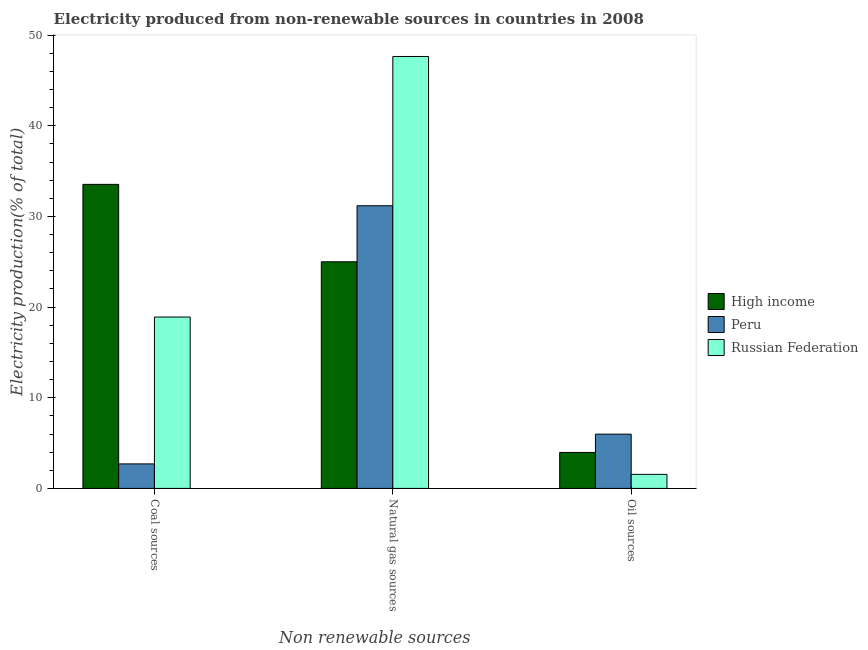How many different coloured bars are there?
Your response must be concise. 3. How many groups of bars are there?
Offer a very short reply. 3. How many bars are there on the 1st tick from the left?
Ensure brevity in your answer.  3. How many bars are there on the 3rd tick from the right?
Your answer should be compact. 3. What is the label of the 3rd group of bars from the left?
Make the answer very short. Oil sources. What is the percentage of electricity produced by natural gas in Peru?
Ensure brevity in your answer.  31.18. Across all countries, what is the maximum percentage of electricity produced by coal?
Provide a succinct answer. 33.54. Across all countries, what is the minimum percentage of electricity produced by coal?
Offer a terse response. 2.7. What is the total percentage of electricity produced by oil sources in the graph?
Provide a short and direct response. 11.5. What is the difference between the percentage of electricity produced by coal in Peru and that in High income?
Make the answer very short. -30.83. What is the difference between the percentage of electricity produced by natural gas in Peru and the percentage of electricity produced by coal in Russian Federation?
Give a very brief answer. 12.28. What is the average percentage of electricity produced by coal per country?
Offer a terse response. 18.38. What is the difference between the percentage of electricity produced by natural gas and percentage of electricity produced by oil sources in Peru?
Your answer should be very brief. 25.19. What is the ratio of the percentage of electricity produced by coal in Russian Federation to that in Peru?
Offer a very short reply. 6.99. Is the percentage of electricity produced by oil sources in Russian Federation less than that in Peru?
Keep it short and to the point. Yes. What is the difference between the highest and the second highest percentage of electricity produced by oil sources?
Your answer should be very brief. 2.02. What is the difference between the highest and the lowest percentage of electricity produced by natural gas?
Offer a terse response. 22.65. In how many countries, is the percentage of electricity produced by coal greater than the average percentage of electricity produced by coal taken over all countries?
Ensure brevity in your answer.  2. What does the 1st bar from the left in Oil sources represents?
Give a very brief answer. High income. Is it the case that in every country, the sum of the percentage of electricity produced by coal and percentage of electricity produced by natural gas is greater than the percentage of electricity produced by oil sources?
Offer a terse response. Yes. Does the graph contain any zero values?
Provide a succinct answer. No. Where does the legend appear in the graph?
Your answer should be compact. Center right. How many legend labels are there?
Give a very brief answer. 3. What is the title of the graph?
Your answer should be very brief. Electricity produced from non-renewable sources in countries in 2008. Does "Swaziland" appear as one of the legend labels in the graph?
Provide a succinct answer. No. What is the label or title of the X-axis?
Your answer should be very brief. Non renewable sources. What is the label or title of the Y-axis?
Offer a terse response. Electricity production(% of total). What is the Electricity production(% of total) in High income in Coal sources?
Ensure brevity in your answer.  33.54. What is the Electricity production(% of total) of Peru in Coal sources?
Your response must be concise. 2.7. What is the Electricity production(% of total) of Russian Federation in Coal sources?
Offer a terse response. 18.9. What is the Electricity production(% of total) of High income in Natural gas sources?
Keep it short and to the point. 25. What is the Electricity production(% of total) of Peru in Natural gas sources?
Give a very brief answer. 31.18. What is the Electricity production(% of total) of Russian Federation in Natural gas sources?
Offer a very short reply. 47.64. What is the Electricity production(% of total) in High income in Oil sources?
Give a very brief answer. 3.97. What is the Electricity production(% of total) in Peru in Oil sources?
Your answer should be compact. 5.99. What is the Electricity production(% of total) in Russian Federation in Oil sources?
Make the answer very short. 1.55. Across all Non renewable sources, what is the maximum Electricity production(% of total) in High income?
Provide a succinct answer. 33.54. Across all Non renewable sources, what is the maximum Electricity production(% of total) in Peru?
Give a very brief answer. 31.18. Across all Non renewable sources, what is the maximum Electricity production(% of total) in Russian Federation?
Your answer should be compact. 47.64. Across all Non renewable sources, what is the minimum Electricity production(% of total) of High income?
Offer a terse response. 3.97. Across all Non renewable sources, what is the minimum Electricity production(% of total) in Peru?
Offer a terse response. 2.7. Across all Non renewable sources, what is the minimum Electricity production(% of total) in Russian Federation?
Give a very brief answer. 1.55. What is the total Electricity production(% of total) in High income in the graph?
Give a very brief answer. 62.5. What is the total Electricity production(% of total) in Peru in the graph?
Provide a short and direct response. 39.87. What is the total Electricity production(% of total) in Russian Federation in the graph?
Give a very brief answer. 68.09. What is the difference between the Electricity production(% of total) in High income in Coal sources and that in Natural gas sources?
Your answer should be compact. 8.54. What is the difference between the Electricity production(% of total) in Peru in Coal sources and that in Natural gas sources?
Offer a very short reply. -28.47. What is the difference between the Electricity production(% of total) in Russian Federation in Coal sources and that in Natural gas sources?
Your answer should be compact. -28.74. What is the difference between the Electricity production(% of total) of High income in Coal sources and that in Oil sources?
Your answer should be very brief. 29.57. What is the difference between the Electricity production(% of total) of Peru in Coal sources and that in Oil sources?
Your answer should be very brief. -3.28. What is the difference between the Electricity production(% of total) of Russian Federation in Coal sources and that in Oil sources?
Your response must be concise. 17.35. What is the difference between the Electricity production(% of total) in High income in Natural gas sources and that in Oil sources?
Your answer should be very brief. 21.03. What is the difference between the Electricity production(% of total) of Peru in Natural gas sources and that in Oil sources?
Your response must be concise. 25.19. What is the difference between the Electricity production(% of total) in Russian Federation in Natural gas sources and that in Oil sources?
Your answer should be very brief. 46.09. What is the difference between the Electricity production(% of total) of High income in Coal sources and the Electricity production(% of total) of Peru in Natural gas sources?
Make the answer very short. 2.36. What is the difference between the Electricity production(% of total) of High income in Coal sources and the Electricity production(% of total) of Russian Federation in Natural gas sources?
Keep it short and to the point. -14.11. What is the difference between the Electricity production(% of total) in Peru in Coal sources and the Electricity production(% of total) in Russian Federation in Natural gas sources?
Offer a very short reply. -44.94. What is the difference between the Electricity production(% of total) in High income in Coal sources and the Electricity production(% of total) in Peru in Oil sources?
Offer a very short reply. 27.55. What is the difference between the Electricity production(% of total) of High income in Coal sources and the Electricity production(% of total) of Russian Federation in Oil sources?
Give a very brief answer. 31.99. What is the difference between the Electricity production(% of total) of Peru in Coal sources and the Electricity production(% of total) of Russian Federation in Oil sources?
Make the answer very short. 1.16. What is the difference between the Electricity production(% of total) in High income in Natural gas sources and the Electricity production(% of total) in Peru in Oil sources?
Ensure brevity in your answer.  19.01. What is the difference between the Electricity production(% of total) of High income in Natural gas sources and the Electricity production(% of total) of Russian Federation in Oil sources?
Give a very brief answer. 23.45. What is the difference between the Electricity production(% of total) of Peru in Natural gas sources and the Electricity production(% of total) of Russian Federation in Oil sources?
Keep it short and to the point. 29.63. What is the average Electricity production(% of total) of High income per Non renewable sources?
Give a very brief answer. 20.83. What is the average Electricity production(% of total) in Peru per Non renewable sources?
Ensure brevity in your answer.  13.29. What is the average Electricity production(% of total) of Russian Federation per Non renewable sources?
Provide a short and direct response. 22.7. What is the difference between the Electricity production(% of total) of High income and Electricity production(% of total) of Peru in Coal sources?
Your response must be concise. 30.83. What is the difference between the Electricity production(% of total) in High income and Electricity production(% of total) in Russian Federation in Coal sources?
Provide a succinct answer. 14.63. What is the difference between the Electricity production(% of total) of Peru and Electricity production(% of total) of Russian Federation in Coal sources?
Your answer should be compact. -16.2. What is the difference between the Electricity production(% of total) in High income and Electricity production(% of total) in Peru in Natural gas sources?
Your answer should be compact. -6.18. What is the difference between the Electricity production(% of total) in High income and Electricity production(% of total) in Russian Federation in Natural gas sources?
Your answer should be very brief. -22.65. What is the difference between the Electricity production(% of total) of Peru and Electricity production(% of total) of Russian Federation in Natural gas sources?
Provide a short and direct response. -16.46. What is the difference between the Electricity production(% of total) in High income and Electricity production(% of total) in Peru in Oil sources?
Keep it short and to the point. -2.02. What is the difference between the Electricity production(% of total) in High income and Electricity production(% of total) in Russian Federation in Oil sources?
Provide a short and direct response. 2.42. What is the difference between the Electricity production(% of total) in Peru and Electricity production(% of total) in Russian Federation in Oil sources?
Keep it short and to the point. 4.44. What is the ratio of the Electricity production(% of total) in High income in Coal sources to that in Natural gas sources?
Provide a short and direct response. 1.34. What is the ratio of the Electricity production(% of total) of Peru in Coal sources to that in Natural gas sources?
Your answer should be very brief. 0.09. What is the ratio of the Electricity production(% of total) of Russian Federation in Coal sources to that in Natural gas sources?
Offer a very short reply. 0.4. What is the ratio of the Electricity production(% of total) of High income in Coal sources to that in Oil sources?
Keep it short and to the point. 8.45. What is the ratio of the Electricity production(% of total) in Peru in Coal sources to that in Oil sources?
Provide a short and direct response. 0.45. What is the ratio of the Electricity production(% of total) in Russian Federation in Coal sources to that in Oil sources?
Give a very brief answer. 12.2. What is the ratio of the Electricity production(% of total) of High income in Natural gas sources to that in Oil sources?
Keep it short and to the point. 6.3. What is the ratio of the Electricity production(% of total) of Peru in Natural gas sources to that in Oil sources?
Your answer should be compact. 5.21. What is the ratio of the Electricity production(% of total) in Russian Federation in Natural gas sources to that in Oil sources?
Ensure brevity in your answer.  30.75. What is the difference between the highest and the second highest Electricity production(% of total) in High income?
Your answer should be very brief. 8.54. What is the difference between the highest and the second highest Electricity production(% of total) in Peru?
Your answer should be very brief. 25.19. What is the difference between the highest and the second highest Electricity production(% of total) in Russian Federation?
Give a very brief answer. 28.74. What is the difference between the highest and the lowest Electricity production(% of total) of High income?
Keep it short and to the point. 29.57. What is the difference between the highest and the lowest Electricity production(% of total) in Peru?
Offer a terse response. 28.47. What is the difference between the highest and the lowest Electricity production(% of total) in Russian Federation?
Ensure brevity in your answer.  46.09. 